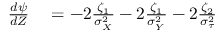Convert formula to latex. <formula><loc_0><loc_0><loc_500><loc_500>\begin{array} { r l } { \frac { d \psi } { d Z } } & = - 2 \frac { \zeta _ { 1 } } { \sigma _ { _ { X } } ^ { 2 } } - 2 \frac { \zeta _ { 1 } } { \sigma _ { _ { Y } } ^ { 2 } } - 2 \frac { \zeta _ { 2 } } { \sigma _ { \tau } ^ { 2 } } } \end{array}</formula> 